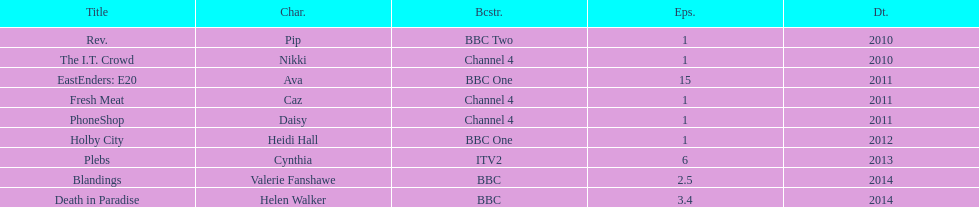How many tv appearances has this actress made? 9. 